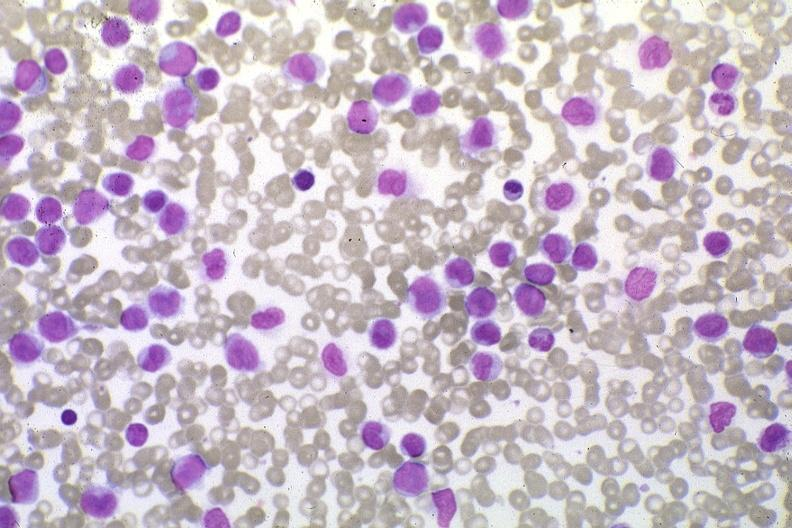what is present?
Answer the question using a single word or phrase. Blood 